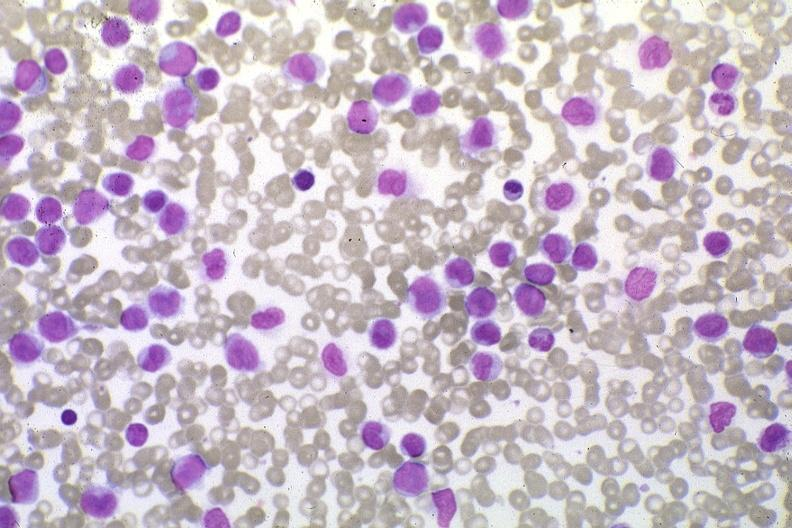what is present?
Answer the question using a single word or phrase. Blood 